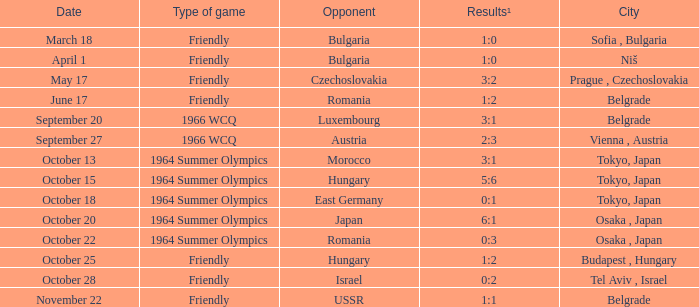Which day had the 3:2 results? May 17. 